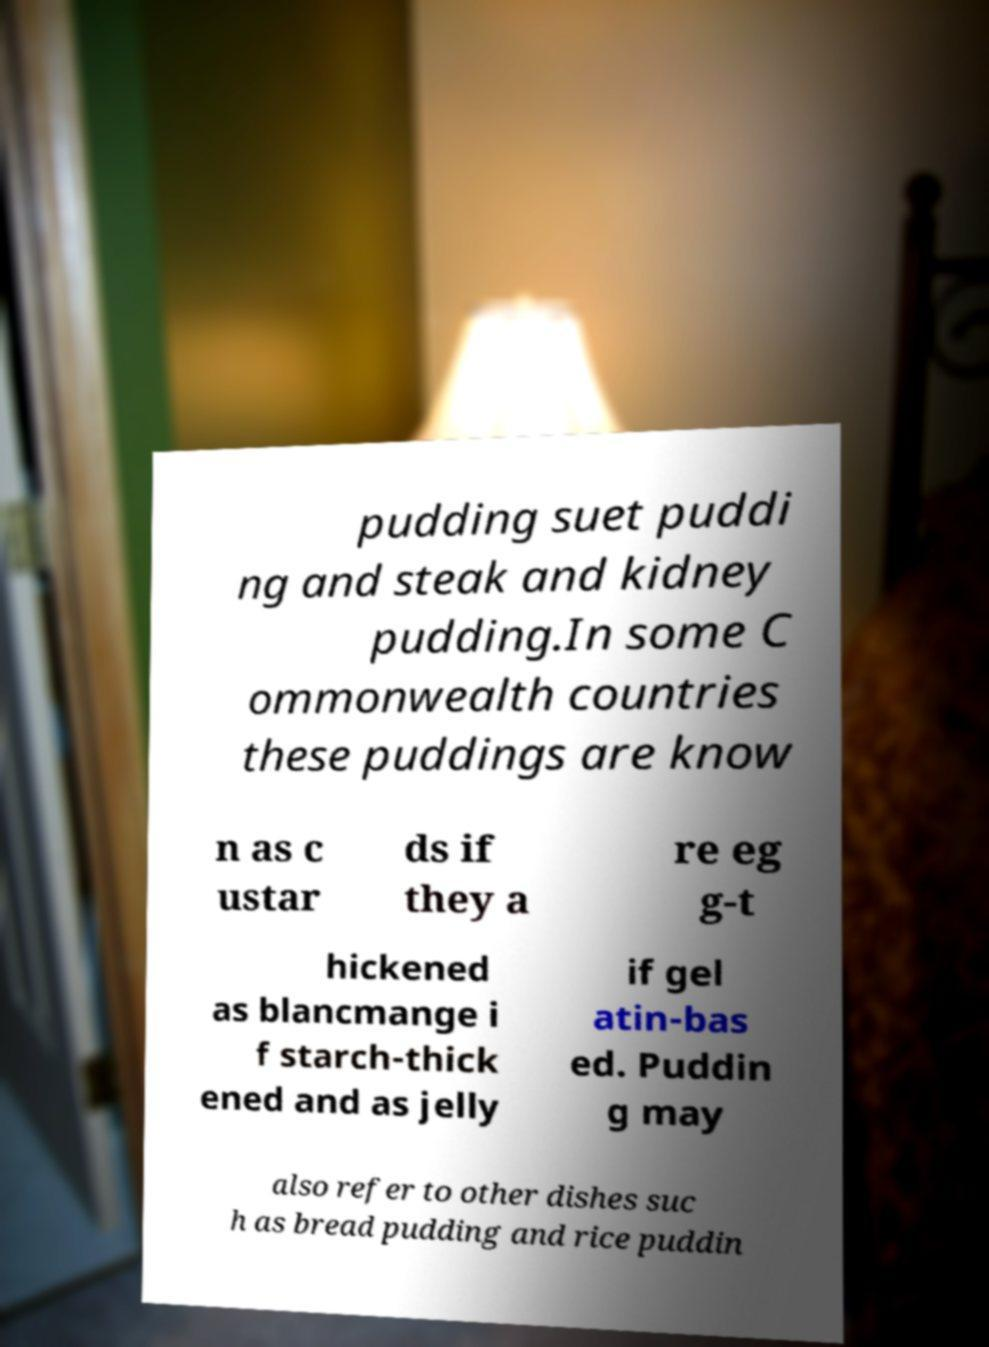Could you extract and type out the text from this image? pudding suet puddi ng and steak and kidney pudding.In some C ommonwealth countries these puddings are know n as c ustar ds if they a re eg g-t hickened as blancmange i f starch-thick ened and as jelly if gel atin-bas ed. Puddin g may also refer to other dishes suc h as bread pudding and rice puddin 